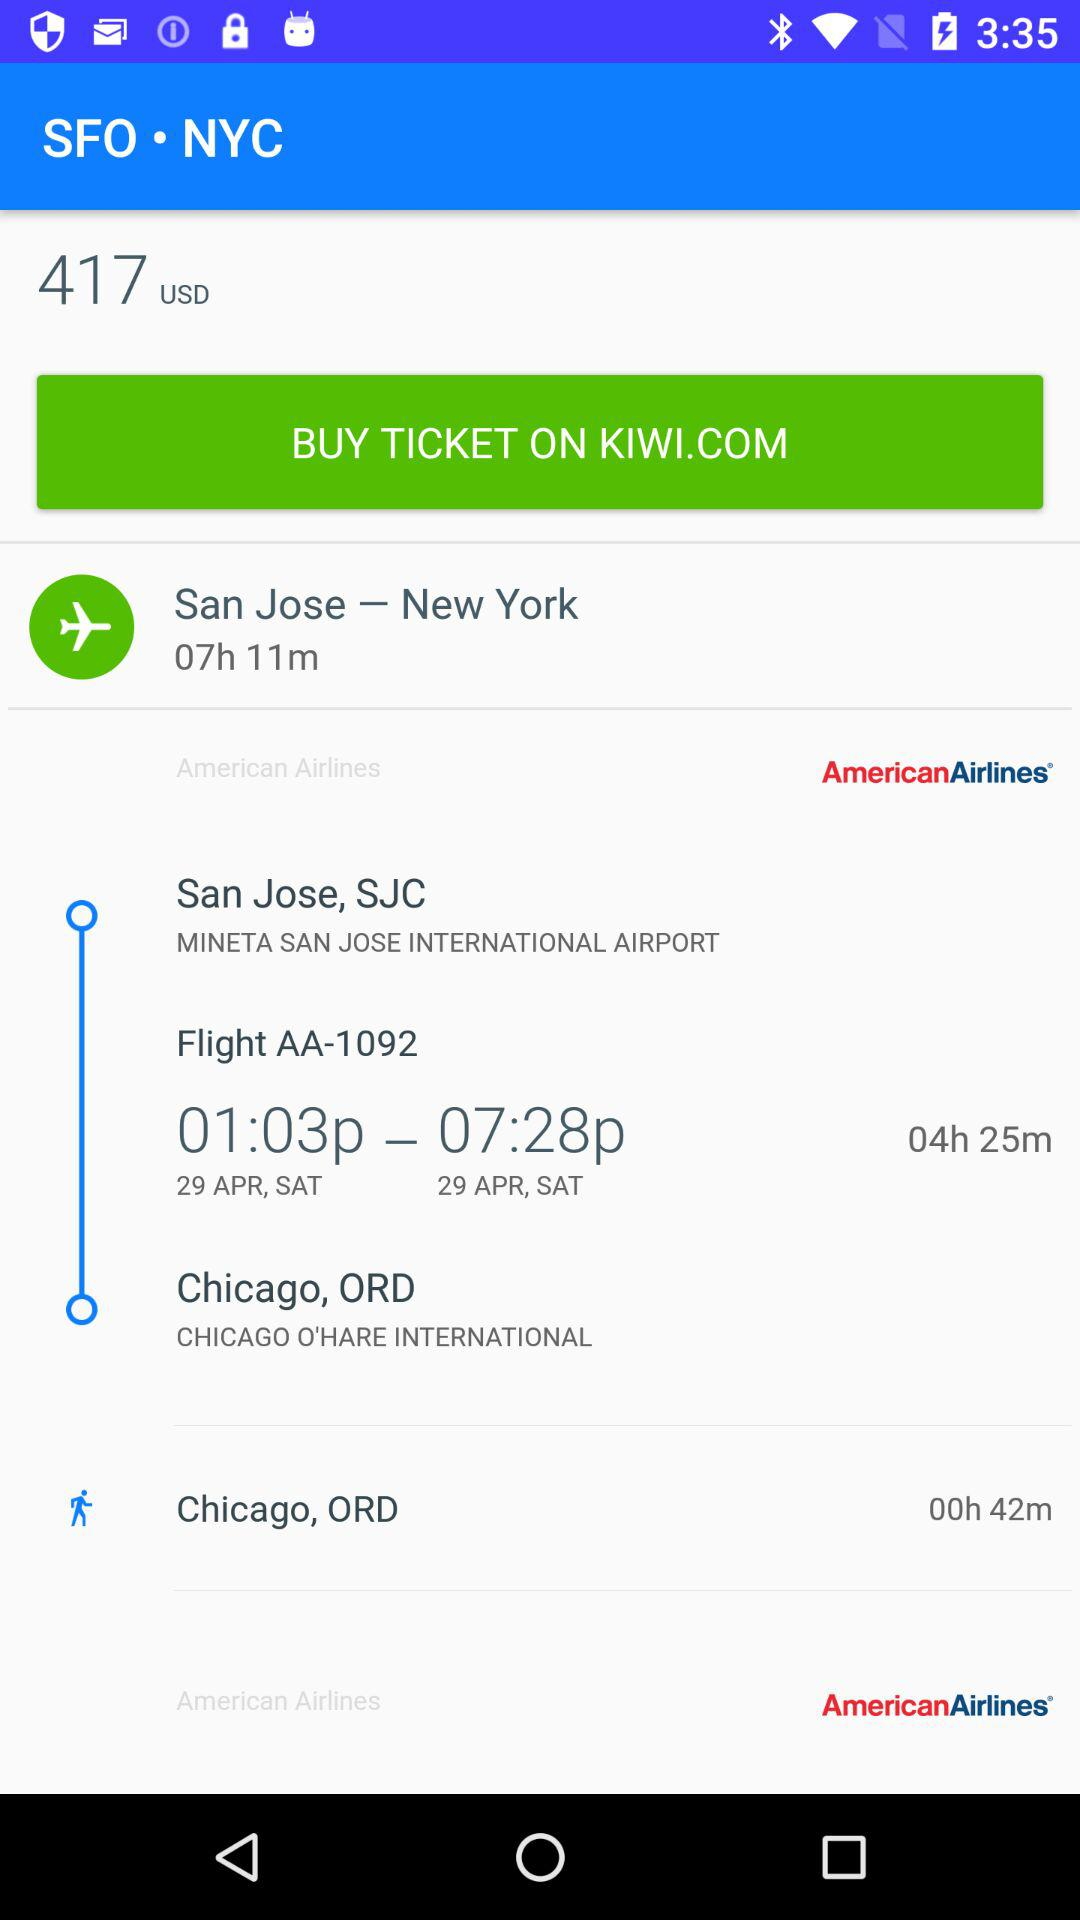What is the airline name? The airline name is American Airlines. 